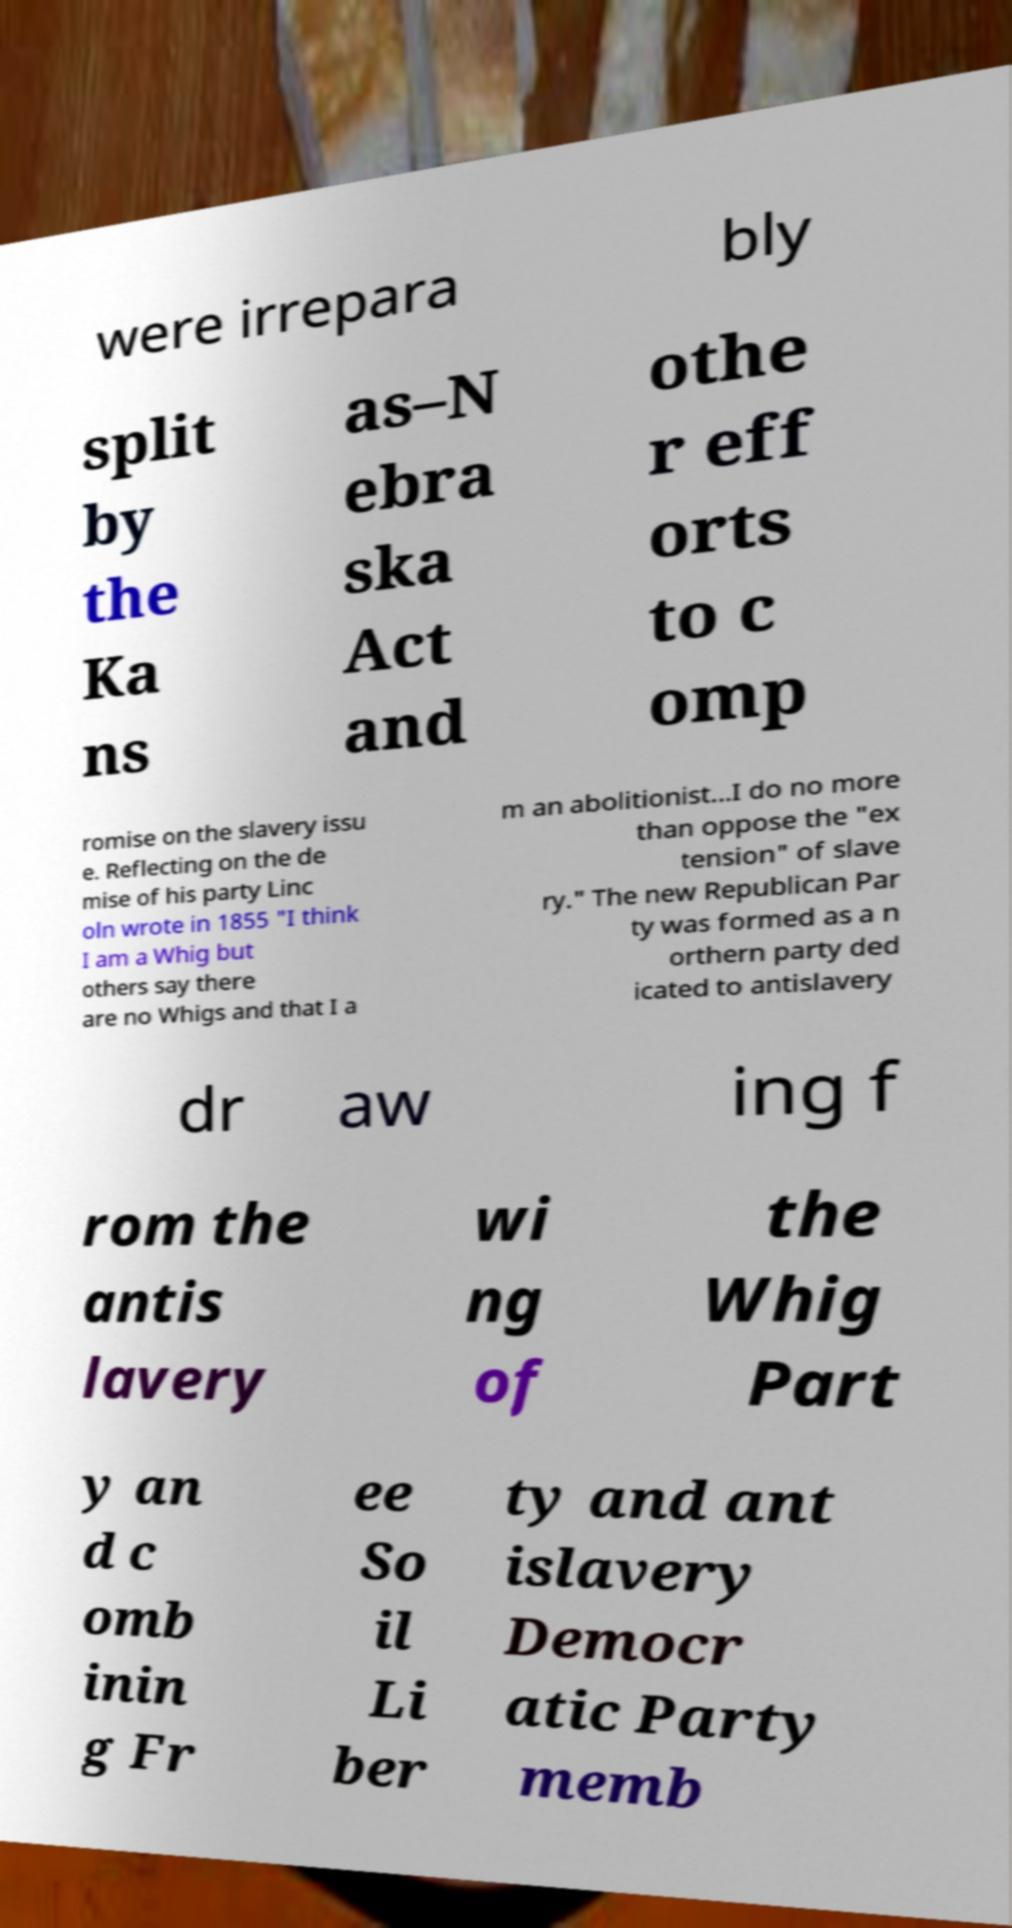What messages or text are displayed in this image? I need them in a readable, typed format. were irrepara bly split by the Ka ns as–N ebra ska Act and othe r eff orts to c omp romise on the slavery issu e. Reflecting on the de mise of his party Linc oln wrote in 1855 "I think I am a Whig but others say there are no Whigs and that I a m an abolitionist...I do no more than oppose the "ex tension" of slave ry." The new Republican Par ty was formed as a n orthern party ded icated to antislavery dr aw ing f rom the antis lavery wi ng of the Whig Part y an d c omb inin g Fr ee So il Li ber ty and ant islavery Democr atic Party memb 